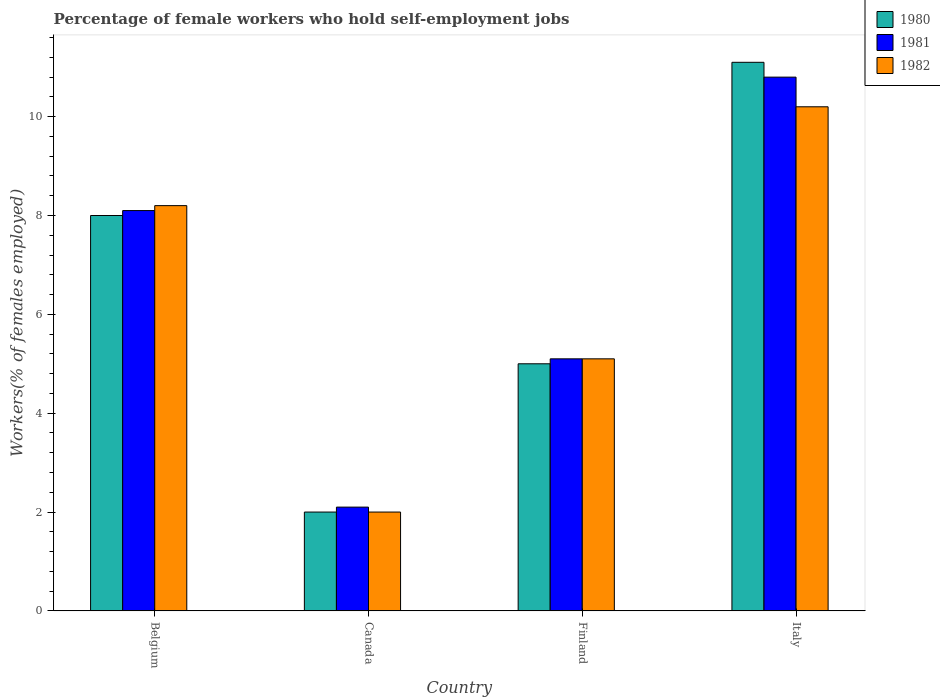How many groups of bars are there?
Provide a short and direct response. 4. Are the number of bars per tick equal to the number of legend labels?
Make the answer very short. Yes. Are the number of bars on each tick of the X-axis equal?
Your answer should be compact. Yes. In how many cases, is the number of bars for a given country not equal to the number of legend labels?
Offer a terse response. 0. Across all countries, what is the maximum percentage of self-employed female workers in 1982?
Ensure brevity in your answer.  10.2. Across all countries, what is the minimum percentage of self-employed female workers in 1980?
Provide a short and direct response. 2. In which country was the percentage of self-employed female workers in 1980 maximum?
Provide a succinct answer. Italy. In which country was the percentage of self-employed female workers in 1980 minimum?
Keep it short and to the point. Canada. What is the total percentage of self-employed female workers in 1982 in the graph?
Your answer should be compact. 25.5. What is the difference between the percentage of self-employed female workers in 1981 in Canada and that in Finland?
Provide a short and direct response. -3. What is the difference between the percentage of self-employed female workers in 1982 in Belgium and the percentage of self-employed female workers in 1980 in Canada?
Keep it short and to the point. 6.2. What is the average percentage of self-employed female workers in 1980 per country?
Your answer should be compact. 6.53. What is the difference between the percentage of self-employed female workers of/in 1980 and percentage of self-employed female workers of/in 1981 in Italy?
Keep it short and to the point. 0.3. In how many countries, is the percentage of self-employed female workers in 1981 greater than 5.2 %?
Your answer should be very brief. 2. What is the ratio of the percentage of self-employed female workers in 1981 in Belgium to that in Italy?
Offer a terse response. 0.75. Is the percentage of self-employed female workers in 1980 in Belgium less than that in Canada?
Provide a succinct answer. No. What is the difference between the highest and the second highest percentage of self-employed female workers in 1982?
Provide a succinct answer. -2. What is the difference between the highest and the lowest percentage of self-employed female workers in 1980?
Make the answer very short. 9.1. Is the sum of the percentage of self-employed female workers in 1981 in Belgium and Canada greater than the maximum percentage of self-employed female workers in 1982 across all countries?
Provide a short and direct response. Yes. What does the 1st bar from the left in Finland represents?
Your answer should be very brief. 1980. How many bars are there?
Your answer should be compact. 12. Are all the bars in the graph horizontal?
Your answer should be very brief. No. How many countries are there in the graph?
Provide a succinct answer. 4. Does the graph contain grids?
Your answer should be compact. No. Where does the legend appear in the graph?
Make the answer very short. Top right. How are the legend labels stacked?
Provide a short and direct response. Vertical. What is the title of the graph?
Provide a short and direct response. Percentage of female workers who hold self-employment jobs. Does "2014" appear as one of the legend labels in the graph?
Offer a very short reply. No. What is the label or title of the Y-axis?
Offer a very short reply. Workers(% of females employed). What is the Workers(% of females employed) in 1980 in Belgium?
Provide a short and direct response. 8. What is the Workers(% of females employed) of 1981 in Belgium?
Make the answer very short. 8.1. What is the Workers(% of females employed) in 1982 in Belgium?
Make the answer very short. 8.2. What is the Workers(% of females employed) in 1980 in Canada?
Ensure brevity in your answer.  2. What is the Workers(% of females employed) of 1981 in Canada?
Keep it short and to the point. 2.1. What is the Workers(% of females employed) in 1980 in Finland?
Give a very brief answer. 5. What is the Workers(% of females employed) of 1981 in Finland?
Offer a terse response. 5.1. What is the Workers(% of females employed) of 1982 in Finland?
Offer a very short reply. 5.1. What is the Workers(% of females employed) of 1980 in Italy?
Ensure brevity in your answer.  11.1. What is the Workers(% of females employed) of 1981 in Italy?
Make the answer very short. 10.8. What is the Workers(% of females employed) in 1982 in Italy?
Provide a succinct answer. 10.2. Across all countries, what is the maximum Workers(% of females employed) in 1980?
Keep it short and to the point. 11.1. Across all countries, what is the maximum Workers(% of females employed) of 1981?
Give a very brief answer. 10.8. Across all countries, what is the maximum Workers(% of females employed) of 1982?
Keep it short and to the point. 10.2. Across all countries, what is the minimum Workers(% of females employed) of 1980?
Offer a terse response. 2. Across all countries, what is the minimum Workers(% of females employed) in 1981?
Keep it short and to the point. 2.1. What is the total Workers(% of females employed) in 1980 in the graph?
Make the answer very short. 26.1. What is the total Workers(% of females employed) of 1981 in the graph?
Make the answer very short. 26.1. What is the difference between the Workers(% of females employed) of 1980 in Belgium and that in Canada?
Your answer should be very brief. 6. What is the difference between the Workers(% of females employed) of 1981 in Belgium and that in Canada?
Offer a terse response. 6. What is the difference between the Workers(% of females employed) of 1980 in Belgium and that in Finland?
Your response must be concise. 3. What is the difference between the Workers(% of females employed) in 1982 in Belgium and that in Finland?
Offer a terse response. 3.1. What is the difference between the Workers(% of females employed) of 1981 in Belgium and that in Italy?
Ensure brevity in your answer.  -2.7. What is the difference between the Workers(% of females employed) of 1982 in Belgium and that in Italy?
Provide a succinct answer. -2. What is the difference between the Workers(% of females employed) in 1981 in Canada and that in Finland?
Provide a short and direct response. -3. What is the difference between the Workers(% of females employed) of 1982 in Canada and that in Finland?
Your answer should be compact. -3.1. What is the difference between the Workers(% of females employed) in 1980 in Finland and that in Italy?
Offer a very short reply. -6.1. What is the difference between the Workers(% of females employed) of 1982 in Finland and that in Italy?
Your answer should be compact. -5.1. What is the difference between the Workers(% of females employed) in 1980 in Belgium and the Workers(% of females employed) in 1982 in Canada?
Ensure brevity in your answer.  6. What is the difference between the Workers(% of females employed) of 1980 in Belgium and the Workers(% of females employed) of 1982 in Finland?
Your answer should be very brief. 2.9. What is the difference between the Workers(% of females employed) of 1980 in Canada and the Workers(% of females employed) of 1982 in Finland?
Offer a terse response. -3.1. What is the difference between the Workers(% of females employed) of 1981 in Canada and the Workers(% of females employed) of 1982 in Finland?
Your answer should be very brief. -3. What is the average Workers(% of females employed) of 1980 per country?
Your answer should be compact. 6.53. What is the average Workers(% of females employed) in 1981 per country?
Your answer should be very brief. 6.53. What is the average Workers(% of females employed) of 1982 per country?
Keep it short and to the point. 6.38. What is the difference between the Workers(% of females employed) of 1980 and Workers(% of females employed) of 1982 in Belgium?
Make the answer very short. -0.2. What is the difference between the Workers(% of females employed) in 1980 and Workers(% of females employed) in 1981 in Canada?
Provide a short and direct response. -0.1. What is the difference between the Workers(% of females employed) in 1981 and Workers(% of females employed) in 1982 in Canada?
Offer a very short reply. 0.1. What is the difference between the Workers(% of females employed) in 1980 and Workers(% of females employed) in 1982 in Finland?
Provide a succinct answer. -0.1. What is the difference between the Workers(% of females employed) in 1981 and Workers(% of females employed) in 1982 in Finland?
Keep it short and to the point. 0. What is the difference between the Workers(% of females employed) in 1980 and Workers(% of females employed) in 1982 in Italy?
Offer a very short reply. 0.9. What is the ratio of the Workers(% of females employed) in 1981 in Belgium to that in Canada?
Keep it short and to the point. 3.86. What is the ratio of the Workers(% of females employed) in 1982 in Belgium to that in Canada?
Make the answer very short. 4.1. What is the ratio of the Workers(% of females employed) in 1981 in Belgium to that in Finland?
Your response must be concise. 1.59. What is the ratio of the Workers(% of females employed) of 1982 in Belgium to that in Finland?
Offer a terse response. 1.61. What is the ratio of the Workers(% of females employed) of 1980 in Belgium to that in Italy?
Give a very brief answer. 0.72. What is the ratio of the Workers(% of females employed) in 1982 in Belgium to that in Italy?
Provide a succinct answer. 0.8. What is the ratio of the Workers(% of females employed) of 1981 in Canada to that in Finland?
Offer a very short reply. 0.41. What is the ratio of the Workers(% of females employed) of 1982 in Canada to that in Finland?
Your answer should be compact. 0.39. What is the ratio of the Workers(% of females employed) in 1980 in Canada to that in Italy?
Keep it short and to the point. 0.18. What is the ratio of the Workers(% of females employed) in 1981 in Canada to that in Italy?
Make the answer very short. 0.19. What is the ratio of the Workers(% of females employed) of 1982 in Canada to that in Italy?
Offer a terse response. 0.2. What is the ratio of the Workers(% of females employed) in 1980 in Finland to that in Italy?
Ensure brevity in your answer.  0.45. What is the ratio of the Workers(% of females employed) in 1981 in Finland to that in Italy?
Provide a succinct answer. 0.47. What is the ratio of the Workers(% of females employed) of 1982 in Finland to that in Italy?
Your answer should be very brief. 0.5. What is the difference between the highest and the second highest Workers(% of females employed) in 1980?
Your answer should be very brief. 3.1. What is the difference between the highest and the second highest Workers(% of females employed) in 1981?
Offer a terse response. 2.7. What is the difference between the highest and the second highest Workers(% of females employed) of 1982?
Offer a very short reply. 2. What is the difference between the highest and the lowest Workers(% of females employed) in 1982?
Your answer should be compact. 8.2. 